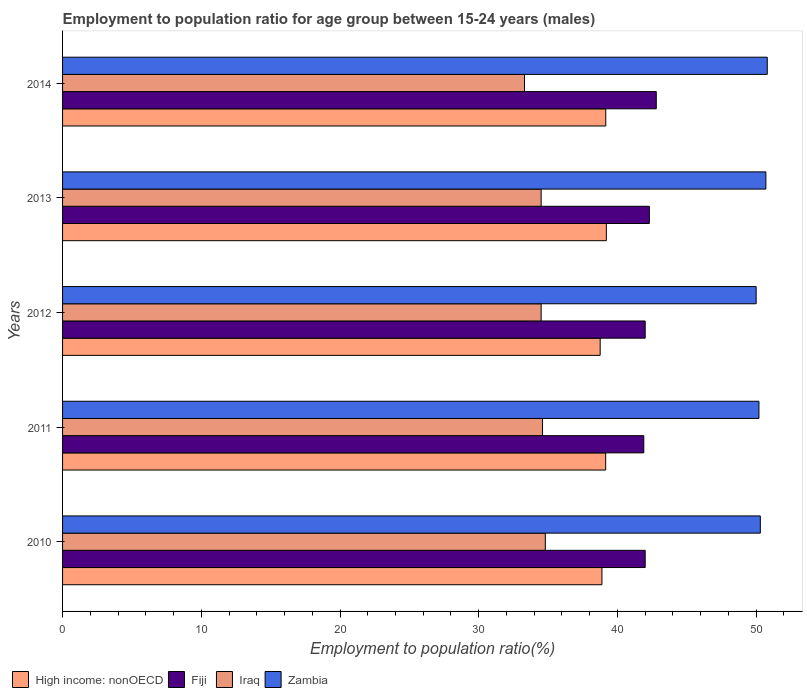Are the number of bars per tick equal to the number of legend labels?
Offer a very short reply. Yes. What is the label of the 4th group of bars from the top?
Your answer should be very brief. 2011. In how many cases, is the number of bars for a given year not equal to the number of legend labels?
Give a very brief answer. 0. What is the employment to population ratio in Fiji in 2013?
Your answer should be very brief. 42.3. Across all years, what is the maximum employment to population ratio in High income: nonOECD?
Ensure brevity in your answer.  39.2. Across all years, what is the minimum employment to population ratio in Iraq?
Provide a succinct answer. 33.3. In which year was the employment to population ratio in Zambia maximum?
Provide a succinct answer. 2014. In which year was the employment to population ratio in Zambia minimum?
Your answer should be compact. 2012. What is the total employment to population ratio in Zambia in the graph?
Make the answer very short. 252. What is the difference between the employment to population ratio in High income: nonOECD in 2011 and that in 2014?
Offer a very short reply. -0.01. What is the difference between the employment to population ratio in Zambia in 2011 and the employment to population ratio in Iraq in 2012?
Ensure brevity in your answer.  15.7. What is the average employment to population ratio in Iraq per year?
Your response must be concise. 34.34. In how many years, is the employment to population ratio in High income: nonOECD greater than 10 %?
Offer a terse response. 5. What is the ratio of the employment to population ratio in Iraq in 2011 to that in 2012?
Make the answer very short. 1. Is the employment to population ratio in Fiji in 2012 less than that in 2014?
Provide a succinct answer. Yes. Is the difference between the employment to population ratio in Zambia in 2012 and 2014 greater than the difference between the employment to population ratio in Iraq in 2012 and 2014?
Your response must be concise. No. What is the difference between the highest and the second highest employment to population ratio in High income: nonOECD?
Provide a succinct answer. 0.04. What is the difference between the highest and the lowest employment to population ratio in High income: nonOECD?
Offer a terse response. 0.45. Is the sum of the employment to population ratio in Iraq in 2012 and 2013 greater than the maximum employment to population ratio in Zambia across all years?
Keep it short and to the point. Yes. Is it the case that in every year, the sum of the employment to population ratio in Fiji and employment to population ratio in Zambia is greater than the sum of employment to population ratio in Iraq and employment to population ratio in High income: nonOECD?
Offer a very short reply. Yes. What does the 2nd bar from the top in 2012 represents?
Your answer should be very brief. Iraq. What does the 1st bar from the bottom in 2010 represents?
Offer a very short reply. High income: nonOECD. Is it the case that in every year, the sum of the employment to population ratio in Fiji and employment to population ratio in Iraq is greater than the employment to population ratio in Zambia?
Offer a very short reply. Yes. Are all the bars in the graph horizontal?
Offer a very short reply. Yes. How many years are there in the graph?
Ensure brevity in your answer.  5. What is the difference between two consecutive major ticks on the X-axis?
Provide a succinct answer. 10. Are the values on the major ticks of X-axis written in scientific E-notation?
Offer a very short reply. No. Does the graph contain any zero values?
Offer a very short reply. No. What is the title of the graph?
Provide a short and direct response. Employment to population ratio for age group between 15-24 years (males). Does "Azerbaijan" appear as one of the legend labels in the graph?
Provide a short and direct response. No. What is the label or title of the X-axis?
Offer a terse response. Employment to population ratio(%). What is the Employment to population ratio(%) of High income: nonOECD in 2010?
Ensure brevity in your answer.  38.88. What is the Employment to population ratio(%) in Iraq in 2010?
Give a very brief answer. 34.8. What is the Employment to population ratio(%) in Zambia in 2010?
Your response must be concise. 50.3. What is the Employment to population ratio(%) in High income: nonOECD in 2011?
Provide a succinct answer. 39.15. What is the Employment to population ratio(%) in Fiji in 2011?
Provide a short and direct response. 41.9. What is the Employment to population ratio(%) in Iraq in 2011?
Ensure brevity in your answer.  34.6. What is the Employment to population ratio(%) of Zambia in 2011?
Your response must be concise. 50.2. What is the Employment to population ratio(%) of High income: nonOECD in 2012?
Provide a succinct answer. 38.76. What is the Employment to population ratio(%) of Iraq in 2012?
Ensure brevity in your answer.  34.5. What is the Employment to population ratio(%) of Zambia in 2012?
Make the answer very short. 50. What is the Employment to population ratio(%) of High income: nonOECD in 2013?
Ensure brevity in your answer.  39.2. What is the Employment to population ratio(%) of Fiji in 2013?
Offer a terse response. 42.3. What is the Employment to population ratio(%) of Iraq in 2013?
Your answer should be compact. 34.5. What is the Employment to population ratio(%) in Zambia in 2013?
Give a very brief answer. 50.7. What is the Employment to population ratio(%) in High income: nonOECD in 2014?
Provide a short and direct response. 39.16. What is the Employment to population ratio(%) in Fiji in 2014?
Keep it short and to the point. 42.8. What is the Employment to population ratio(%) in Iraq in 2014?
Make the answer very short. 33.3. What is the Employment to population ratio(%) of Zambia in 2014?
Ensure brevity in your answer.  50.8. Across all years, what is the maximum Employment to population ratio(%) in High income: nonOECD?
Make the answer very short. 39.2. Across all years, what is the maximum Employment to population ratio(%) in Fiji?
Your answer should be very brief. 42.8. Across all years, what is the maximum Employment to population ratio(%) in Iraq?
Your answer should be very brief. 34.8. Across all years, what is the maximum Employment to population ratio(%) in Zambia?
Ensure brevity in your answer.  50.8. Across all years, what is the minimum Employment to population ratio(%) in High income: nonOECD?
Provide a succinct answer. 38.76. Across all years, what is the minimum Employment to population ratio(%) of Fiji?
Your answer should be very brief. 41.9. Across all years, what is the minimum Employment to population ratio(%) of Iraq?
Your answer should be very brief. 33.3. Across all years, what is the minimum Employment to population ratio(%) in Zambia?
Make the answer very short. 50. What is the total Employment to population ratio(%) of High income: nonOECD in the graph?
Make the answer very short. 195.15. What is the total Employment to population ratio(%) of Fiji in the graph?
Make the answer very short. 211. What is the total Employment to population ratio(%) in Iraq in the graph?
Offer a very short reply. 171.7. What is the total Employment to population ratio(%) of Zambia in the graph?
Provide a short and direct response. 252. What is the difference between the Employment to population ratio(%) of High income: nonOECD in 2010 and that in 2011?
Your response must be concise. -0.27. What is the difference between the Employment to population ratio(%) in Fiji in 2010 and that in 2011?
Give a very brief answer. 0.1. What is the difference between the Employment to population ratio(%) in Iraq in 2010 and that in 2011?
Keep it short and to the point. 0.2. What is the difference between the Employment to population ratio(%) of Zambia in 2010 and that in 2011?
Offer a very short reply. 0.1. What is the difference between the Employment to population ratio(%) in High income: nonOECD in 2010 and that in 2012?
Offer a terse response. 0.13. What is the difference between the Employment to population ratio(%) in Fiji in 2010 and that in 2012?
Your answer should be compact. 0. What is the difference between the Employment to population ratio(%) of Iraq in 2010 and that in 2012?
Provide a succinct answer. 0.3. What is the difference between the Employment to population ratio(%) in High income: nonOECD in 2010 and that in 2013?
Your answer should be compact. -0.32. What is the difference between the Employment to population ratio(%) of Iraq in 2010 and that in 2013?
Your answer should be very brief. 0.3. What is the difference between the Employment to population ratio(%) of High income: nonOECD in 2010 and that in 2014?
Your response must be concise. -0.28. What is the difference between the Employment to population ratio(%) in Iraq in 2010 and that in 2014?
Ensure brevity in your answer.  1.5. What is the difference between the Employment to population ratio(%) in Zambia in 2010 and that in 2014?
Offer a very short reply. -0.5. What is the difference between the Employment to population ratio(%) of High income: nonOECD in 2011 and that in 2012?
Make the answer very short. 0.4. What is the difference between the Employment to population ratio(%) of Zambia in 2011 and that in 2012?
Your answer should be compact. 0.2. What is the difference between the Employment to population ratio(%) in High income: nonOECD in 2011 and that in 2013?
Provide a short and direct response. -0.05. What is the difference between the Employment to population ratio(%) of Iraq in 2011 and that in 2013?
Give a very brief answer. 0.1. What is the difference between the Employment to population ratio(%) of High income: nonOECD in 2011 and that in 2014?
Offer a very short reply. -0.01. What is the difference between the Employment to population ratio(%) of Fiji in 2011 and that in 2014?
Your response must be concise. -0.9. What is the difference between the Employment to population ratio(%) in Iraq in 2011 and that in 2014?
Your answer should be very brief. 1.3. What is the difference between the Employment to population ratio(%) in High income: nonOECD in 2012 and that in 2013?
Ensure brevity in your answer.  -0.45. What is the difference between the Employment to population ratio(%) of Fiji in 2012 and that in 2013?
Your answer should be compact. -0.3. What is the difference between the Employment to population ratio(%) in High income: nonOECD in 2012 and that in 2014?
Provide a short and direct response. -0.4. What is the difference between the Employment to population ratio(%) in Iraq in 2012 and that in 2014?
Provide a short and direct response. 1.2. What is the difference between the Employment to population ratio(%) in Zambia in 2012 and that in 2014?
Give a very brief answer. -0.8. What is the difference between the Employment to population ratio(%) of High income: nonOECD in 2013 and that in 2014?
Your answer should be very brief. 0.04. What is the difference between the Employment to population ratio(%) of Zambia in 2013 and that in 2014?
Your response must be concise. -0.1. What is the difference between the Employment to population ratio(%) in High income: nonOECD in 2010 and the Employment to population ratio(%) in Fiji in 2011?
Make the answer very short. -3.02. What is the difference between the Employment to population ratio(%) of High income: nonOECD in 2010 and the Employment to population ratio(%) of Iraq in 2011?
Provide a succinct answer. 4.28. What is the difference between the Employment to population ratio(%) in High income: nonOECD in 2010 and the Employment to population ratio(%) in Zambia in 2011?
Offer a terse response. -11.32. What is the difference between the Employment to population ratio(%) in Iraq in 2010 and the Employment to population ratio(%) in Zambia in 2011?
Offer a terse response. -15.4. What is the difference between the Employment to population ratio(%) of High income: nonOECD in 2010 and the Employment to population ratio(%) of Fiji in 2012?
Provide a succinct answer. -3.12. What is the difference between the Employment to population ratio(%) of High income: nonOECD in 2010 and the Employment to population ratio(%) of Iraq in 2012?
Ensure brevity in your answer.  4.38. What is the difference between the Employment to population ratio(%) in High income: nonOECD in 2010 and the Employment to population ratio(%) in Zambia in 2012?
Provide a short and direct response. -11.12. What is the difference between the Employment to population ratio(%) in Iraq in 2010 and the Employment to population ratio(%) in Zambia in 2012?
Provide a short and direct response. -15.2. What is the difference between the Employment to population ratio(%) in High income: nonOECD in 2010 and the Employment to population ratio(%) in Fiji in 2013?
Make the answer very short. -3.42. What is the difference between the Employment to population ratio(%) of High income: nonOECD in 2010 and the Employment to population ratio(%) of Iraq in 2013?
Offer a terse response. 4.38. What is the difference between the Employment to population ratio(%) of High income: nonOECD in 2010 and the Employment to population ratio(%) of Zambia in 2013?
Your response must be concise. -11.82. What is the difference between the Employment to population ratio(%) in Iraq in 2010 and the Employment to population ratio(%) in Zambia in 2013?
Provide a succinct answer. -15.9. What is the difference between the Employment to population ratio(%) of High income: nonOECD in 2010 and the Employment to population ratio(%) of Fiji in 2014?
Your answer should be very brief. -3.92. What is the difference between the Employment to population ratio(%) of High income: nonOECD in 2010 and the Employment to population ratio(%) of Iraq in 2014?
Keep it short and to the point. 5.58. What is the difference between the Employment to population ratio(%) of High income: nonOECD in 2010 and the Employment to population ratio(%) of Zambia in 2014?
Provide a succinct answer. -11.92. What is the difference between the Employment to population ratio(%) of Fiji in 2010 and the Employment to population ratio(%) of Zambia in 2014?
Your response must be concise. -8.8. What is the difference between the Employment to population ratio(%) in Iraq in 2010 and the Employment to population ratio(%) in Zambia in 2014?
Keep it short and to the point. -16. What is the difference between the Employment to population ratio(%) of High income: nonOECD in 2011 and the Employment to population ratio(%) of Fiji in 2012?
Your response must be concise. -2.85. What is the difference between the Employment to population ratio(%) of High income: nonOECD in 2011 and the Employment to population ratio(%) of Iraq in 2012?
Your answer should be very brief. 4.65. What is the difference between the Employment to population ratio(%) of High income: nonOECD in 2011 and the Employment to population ratio(%) of Zambia in 2012?
Ensure brevity in your answer.  -10.85. What is the difference between the Employment to population ratio(%) of Fiji in 2011 and the Employment to population ratio(%) of Zambia in 2012?
Your response must be concise. -8.1. What is the difference between the Employment to population ratio(%) in Iraq in 2011 and the Employment to population ratio(%) in Zambia in 2012?
Keep it short and to the point. -15.4. What is the difference between the Employment to population ratio(%) in High income: nonOECD in 2011 and the Employment to population ratio(%) in Fiji in 2013?
Provide a short and direct response. -3.15. What is the difference between the Employment to population ratio(%) of High income: nonOECD in 2011 and the Employment to population ratio(%) of Iraq in 2013?
Offer a terse response. 4.65. What is the difference between the Employment to population ratio(%) in High income: nonOECD in 2011 and the Employment to population ratio(%) in Zambia in 2013?
Give a very brief answer. -11.55. What is the difference between the Employment to population ratio(%) in Iraq in 2011 and the Employment to population ratio(%) in Zambia in 2013?
Your response must be concise. -16.1. What is the difference between the Employment to population ratio(%) of High income: nonOECD in 2011 and the Employment to population ratio(%) of Fiji in 2014?
Give a very brief answer. -3.65. What is the difference between the Employment to population ratio(%) of High income: nonOECD in 2011 and the Employment to population ratio(%) of Iraq in 2014?
Ensure brevity in your answer.  5.85. What is the difference between the Employment to population ratio(%) in High income: nonOECD in 2011 and the Employment to population ratio(%) in Zambia in 2014?
Offer a terse response. -11.65. What is the difference between the Employment to population ratio(%) of Iraq in 2011 and the Employment to population ratio(%) of Zambia in 2014?
Offer a terse response. -16.2. What is the difference between the Employment to population ratio(%) in High income: nonOECD in 2012 and the Employment to population ratio(%) in Fiji in 2013?
Provide a succinct answer. -3.54. What is the difference between the Employment to population ratio(%) in High income: nonOECD in 2012 and the Employment to population ratio(%) in Iraq in 2013?
Ensure brevity in your answer.  4.26. What is the difference between the Employment to population ratio(%) of High income: nonOECD in 2012 and the Employment to population ratio(%) of Zambia in 2013?
Keep it short and to the point. -11.94. What is the difference between the Employment to population ratio(%) in Fiji in 2012 and the Employment to population ratio(%) in Iraq in 2013?
Provide a succinct answer. 7.5. What is the difference between the Employment to population ratio(%) in Iraq in 2012 and the Employment to population ratio(%) in Zambia in 2013?
Provide a short and direct response. -16.2. What is the difference between the Employment to population ratio(%) in High income: nonOECD in 2012 and the Employment to population ratio(%) in Fiji in 2014?
Your answer should be very brief. -4.04. What is the difference between the Employment to population ratio(%) of High income: nonOECD in 2012 and the Employment to population ratio(%) of Iraq in 2014?
Offer a terse response. 5.46. What is the difference between the Employment to population ratio(%) of High income: nonOECD in 2012 and the Employment to population ratio(%) of Zambia in 2014?
Give a very brief answer. -12.04. What is the difference between the Employment to population ratio(%) of Fiji in 2012 and the Employment to population ratio(%) of Iraq in 2014?
Offer a terse response. 8.7. What is the difference between the Employment to population ratio(%) in Iraq in 2012 and the Employment to population ratio(%) in Zambia in 2014?
Give a very brief answer. -16.3. What is the difference between the Employment to population ratio(%) of High income: nonOECD in 2013 and the Employment to population ratio(%) of Fiji in 2014?
Ensure brevity in your answer.  -3.6. What is the difference between the Employment to population ratio(%) of High income: nonOECD in 2013 and the Employment to population ratio(%) of Iraq in 2014?
Give a very brief answer. 5.9. What is the difference between the Employment to population ratio(%) of High income: nonOECD in 2013 and the Employment to population ratio(%) of Zambia in 2014?
Ensure brevity in your answer.  -11.6. What is the difference between the Employment to population ratio(%) of Fiji in 2013 and the Employment to population ratio(%) of Iraq in 2014?
Your answer should be compact. 9. What is the difference between the Employment to population ratio(%) of Iraq in 2013 and the Employment to population ratio(%) of Zambia in 2014?
Provide a succinct answer. -16.3. What is the average Employment to population ratio(%) in High income: nonOECD per year?
Your answer should be compact. 39.03. What is the average Employment to population ratio(%) in Fiji per year?
Your response must be concise. 42.2. What is the average Employment to population ratio(%) of Iraq per year?
Ensure brevity in your answer.  34.34. What is the average Employment to population ratio(%) in Zambia per year?
Your answer should be very brief. 50.4. In the year 2010, what is the difference between the Employment to population ratio(%) of High income: nonOECD and Employment to population ratio(%) of Fiji?
Give a very brief answer. -3.12. In the year 2010, what is the difference between the Employment to population ratio(%) of High income: nonOECD and Employment to population ratio(%) of Iraq?
Your answer should be very brief. 4.08. In the year 2010, what is the difference between the Employment to population ratio(%) of High income: nonOECD and Employment to population ratio(%) of Zambia?
Offer a very short reply. -11.42. In the year 2010, what is the difference between the Employment to population ratio(%) of Fiji and Employment to population ratio(%) of Iraq?
Provide a succinct answer. 7.2. In the year 2010, what is the difference between the Employment to population ratio(%) of Iraq and Employment to population ratio(%) of Zambia?
Keep it short and to the point. -15.5. In the year 2011, what is the difference between the Employment to population ratio(%) of High income: nonOECD and Employment to population ratio(%) of Fiji?
Your answer should be very brief. -2.75. In the year 2011, what is the difference between the Employment to population ratio(%) of High income: nonOECD and Employment to population ratio(%) of Iraq?
Give a very brief answer. 4.55. In the year 2011, what is the difference between the Employment to population ratio(%) in High income: nonOECD and Employment to population ratio(%) in Zambia?
Make the answer very short. -11.05. In the year 2011, what is the difference between the Employment to population ratio(%) of Fiji and Employment to population ratio(%) of Iraq?
Offer a very short reply. 7.3. In the year 2011, what is the difference between the Employment to population ratio(%) in Fiji and Employment to population ratio(%) in Zambia?
Make the answer very short. -8.3. In the year 2011, what is the difference between the Employment to population ratio(%) in Iraq and Employment to population ratio(%) in Zambia?
Provide a short and direct response. -15.6. In the year 2012, what is the difference between the Employment to population ratio(%) in High income: nonOECD and Employment to population ratio(%) in Fiji?
Provide a succinct answer. -3.24. In the year 2012, what is the difference between the Employment to population ratio(%) of High income: nonOECD and Employment to population ratio(%) of Iraq?
Make the answer very short. 4.26. In the year 2012, what is the difference between the Employment to population ratio(%) of High income: nonOECD and Employment to population ratio(%) of Zambia?
Provide a short and direct response. -11.24. In the year 2012, what is the difference between the Employment to population ratio(%) in Fiji and Employment to population ratio(%) in Iraq?
Offer a terse response. 7.5. In the year 2012, what is the difference between the Employment to population ratio(%) of Iraq and Employment to population ratio(%) of Zambia?
Ensure brevity in your answer.  -15.5. In the year 2013, what is the difference between the Employment to population ratio(%) of High income: nonOECD and Employment to population ratio(%) of Fiji?
Make the answer very short. -3.1. In the year 2013, what is the difference between the Employment to population ratio(%) of High income: nonOECD and Employment to population ratio(%) of Iraq?
Provide a short and direct response. 4.7. In the year 2013, what is the difference between the Employment to population ratio(%) in High income: nonOECD and Employment to population ratio(%) in Zambia?
Your answer should be very brief. -11.5. In the year 2013, what is the difference between the Employment to population ratio(%) of Fiji and Employment to population ratio(%) of Iraq?
Your answer should be compact. 7.8. In the year 2013, what is the difference between the Employment to population ratio(%) in Fiji and Employment to population ratio(%) in Zambia?
Your response must be concise. -8.4. In the year 2013, what is the difference between the Employment to population ratio(%) in Iraq and Employment to population ratio(%) in Zambia?
Give a very brief answer. -16.2. In the year 2014, what is the difference between the Employment to population ratio(%) of High income: nonOECD and Employment to population ratio(%) of Fiji?
Give a very brief answer. -3.64. In the year 2014, what is the difference between the Employment to population ratio(%) of High income: nonOECD and Employment to population ratio(%) of Iraq?
Your answer should be compact. 5.86. In the year 2014, what is the difference between the Employment to population ratio(%) of High income: nonOECD and Employment to population ratio(%) of Zambia?
Make the answer very short. -11.64. In the year 2014, what is the difference between the Employment to population ratio(%) of Fiji and Employment to population ratio(%) of Iraq?
Ensure brevity in your answer.  9.5. In the year 2014, what is the difference between the Employment to population ratio(%) in Iraq and Employment to population ratio(%) in Zambia?
Provide a short and direct response. -17.5. What is the ratio of the Employment to population ratio(%) in High income: nonOECD in 2010 to that in 2011?
Give a very brief answer. 0.99. What is the ratio of the Employment to population ratio(%) of Fiji in 2010 to that in 2011?
Provide a succinct answer. 1. What is the ratio of the Employment to population ratio(%) in High income: nonOECD in 2010 to that in 2012?
Keep it short and to the point. 1. What is the ratio of the Employment to population ratio(%) of Fiji in 2010 to that in 2012?
Provide a short and direct response. 1. What is the ratio of the Employment to population ratio(%) of Iraq in 2010 to that in 2012?
Your answer should be very brief. 1.01. What is the ratio of the Employment to population ratio(%) in Zambia in 2010 to that in 2012?
Give a very brief answer. 1.01. What is the ratio of the Employment to population ratio(%) in Fiji in 2010 to that in 2013?
Give a very brief answer. 0.99. What is the ratio of the Employment to population ratio(%) in Iraq in 2010 to that in 2013?
Provide a short and direct response. 1.01. What is the ratio of the Employment to population ratio(%) in High income: nonOECD in 2010 to that in 2014?
Offer a terse response. 0.99. What is the ratio of the Employment to population ratio(%) of Fiji in 2010 to that in 2014?
Give a very brief answer. 0.98. What is the ratio of the Employment to population ratio(%) in Iraq in 2010 to that in 2014?
Your answer should be compact. 1.04. What is the ratio of the Employment to population ratio(%) in Zambia in 2010 to that in 2014?
Your answer should be compact. 0.99. What is the ratio of the Employment to population ratio(%) in High income: nonOECD in 2011 to that in 2012?
Your answer should be compact. 1.01. What is the ratio of the Employment to population ratio(%) in High income: nonOECD in 2011 to that in 2013?
Offer a terse response. 1. What is the ratio of the Employment to population ratio(%) of Fiji in 2011 to that in 2013?
Provide a short and direct response. 0.99. What is the ratio of the Employment to population ratio(%) of Iraq in 2011 to that in 2013?
Make the answer very short. 1. What is the ratio of the Employment to population ratio(%) in High income: nonOECD in 2011 to that in 2014?
Keep it short and to the point. 1. What is the ratio of the Employment to population ratio(%) in Iraq in 2011 to that in 2014?
Provide a short and direct response. 1.04. What is the ratio of the Employment to population ratio(%) of High income: nonOECD in 2012 to that in 2013?
Your response must be concise. 0.99. What is the ratio of the Employment to population ratio(%) of Fiji in 2012 to that in 2013?
Offer a very short reply. 0.99. What is the ratio of the Employment to population ratio(%) of Iraq in 2012 to that in 2013?
Your response must be concise. 1. What is the ratio of the Employment to population ratio(%) of Zambia in 2012 to that in 2013?
Make the answer very short. 0.99. What is the ratio of the Employment to population ratio(%) in Fiji in 2012 to that in 2014?
Provide a short and direct response. 0.98. What is the ratio of the Employment to population ratio(%) in Iraq in 2012 to that in 2014?
Give a very brief answer. 1.04. What is the ratio of the Employment to population ratio(%) of Zambia in 2012 to that in 2014?
Give a very brief answer. 0.98. What is the ratio of the Employment to population ratio(%) of High income: nonOECD in 2013 to that in 2014?
Ensure brevity in your answer.  1. What is the ratio of the Employment to population ratio(%) in Fiji in 2013 to that in 2014?
Provide a succinct answer. 0.99. What is the ratio of the Employment to population ratio(%) in Iraq in 2013 to that in 2014?
Your response must be concise. 1.04. What is the ratio of the Employment to population ratio(%) in Zambia in 2013 to that in 2014?
Your answer should be very brief. 1. What is the difference between the highest and the second highest Employment to population ratio(%) in High income: nonOECD?
Offer a very short reply. 0.04. What is the difference between the highest and the second highest Employment to population ratio(%) in Iraq?
Your response must be concise. 0.2. What is the difference between the highest and the second highest Employment to population ratio(%) in Zambia?
Offer a very short reply. 0.1. What is the difference between the highest and the lowest Employment to population ratio(%) in High income: nonOECD?
Your answer should be compact. 0.45. What is the difference between the highest and the lowest Employment to population ratio(%) in Iraq?
Your answer should be very brief. 1.5. 